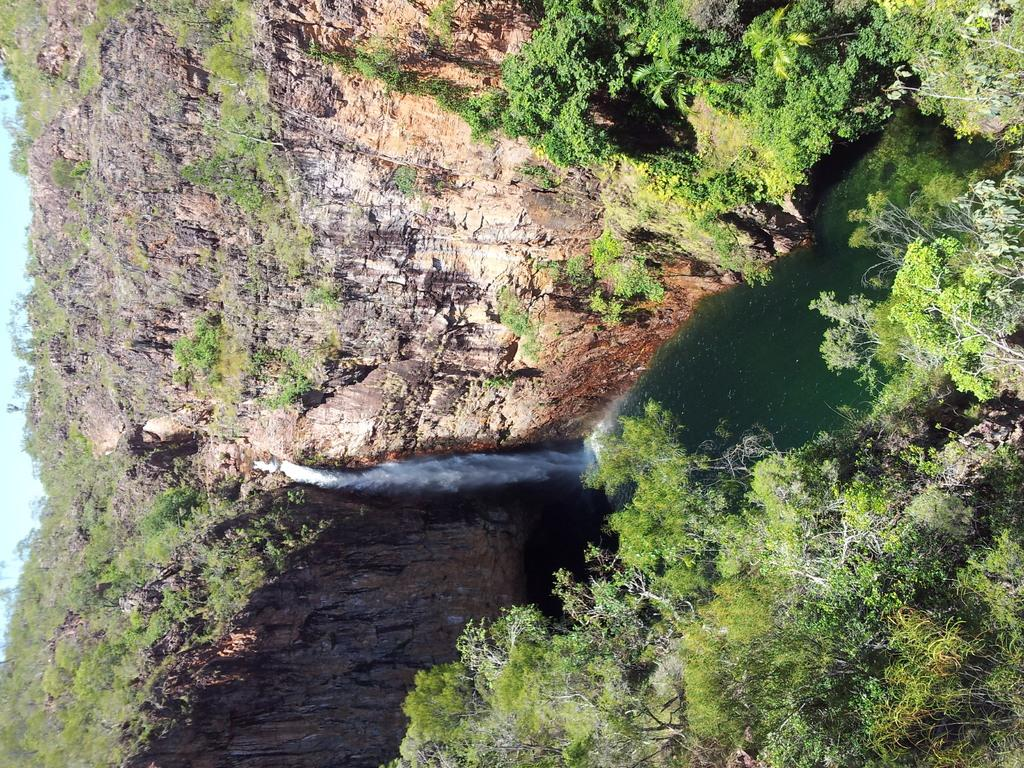What type of vegetation can be seen in the image? There are trees in the image. What is the color of the trees? The trees are green in color. What else can be seen in the image besides the trees? There is water visible in the image, as well as a mountain and the sky in the background. What is happening with the water in the image? Water is falling from the mountain in the image. What type of magic is being performed in the room in the image? There is no room or magic present in the image; it features trees, water, a mountain, and the sky. What kind of apparatus is used to create the waterfall in the image? There is no apparatus visible in the image; the water is falling naturally from the mountain. 